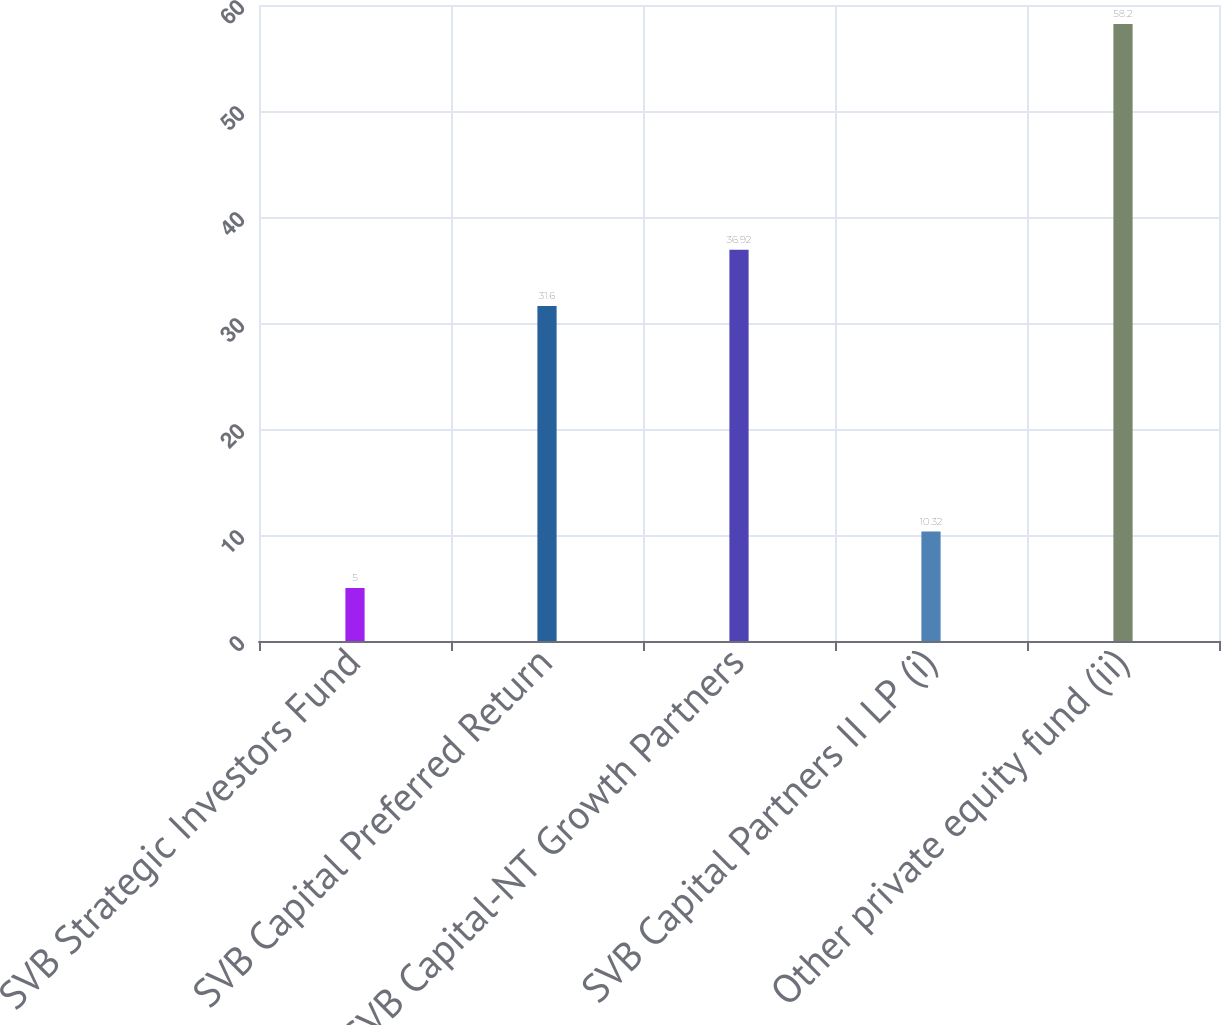Convert chart to OTSL. <chart><loc_0><loc_0><loc_500><loc_500><bar_chart><fcel>SVB Strategic Investors Fund<fcel>SVB Capital Preferred Return<fcel>SVB Capital-NT Growth Partners<fcel>SVB Capital Partners II LP (i)<fcel>Other private equity fund (ii)<nl><fcel>5<fcel>31.6<fcel>36.92<fcel>10.32<fcel>58.2<nl></chart> 